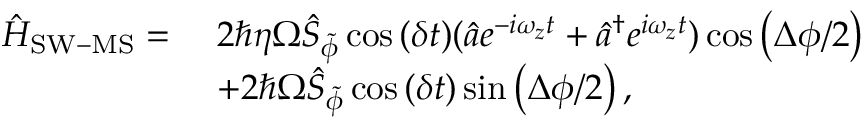<formula> <loc_0><loc_0><loc_500><loc_500>\begin{array} { r l } { \hat { H } _ { S W - M S } = \ } & { 2 \hbar { \eta } \Omega \hat { S } _ { \tilde { \phi } } \cos { ( \delta t ) } ( \hat { a } e ^ { - i \omega _ { z } t } + \hat { a } ^ { \dagger } e ^ { i \omega _ { z } t } ) \cos { \left ( \Delta \phi / 2 \right ) } } \\ & { + 2 \hbar { \Omega } \hat { S } _ { \tilde { \phi } } \cos { ( \delta t ) } \sin { \left ( \Delta \phi / 2 \right ) , } } \end{array}</formula> 